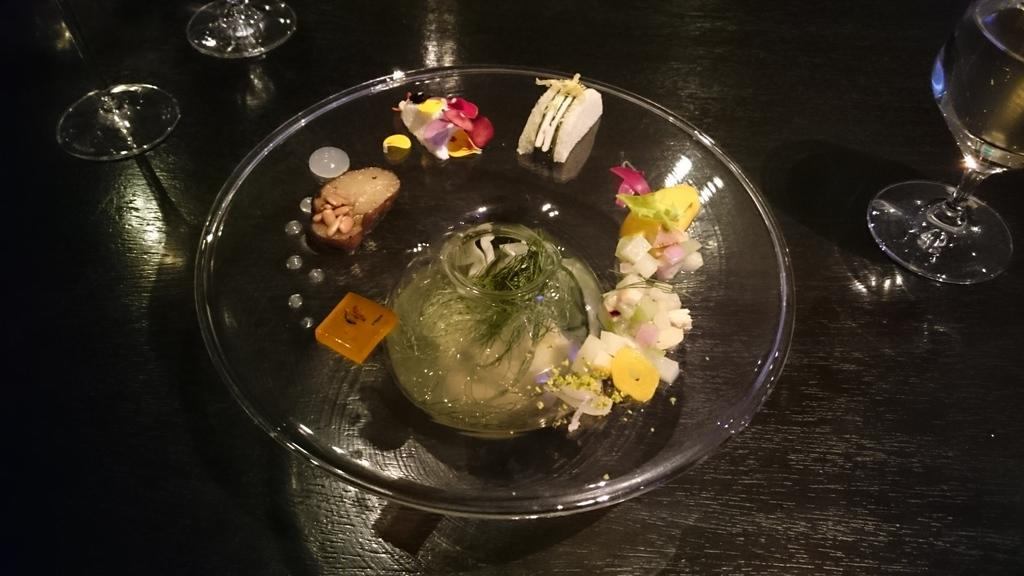What is on the plate that is visible in the image? There is a plate with food items in the image. What else can be seen in the image besides the plate? There are glasses visible in the image. Where are the plate and glasses located in the image? The plate and glasses are placed on a platform. What type of cord is connected to the plate in the image? There is no cord connected to the plate in the image. How does the nut help in the expansion of the food items in the image? There is no nut or expansion of food items present in the image. 